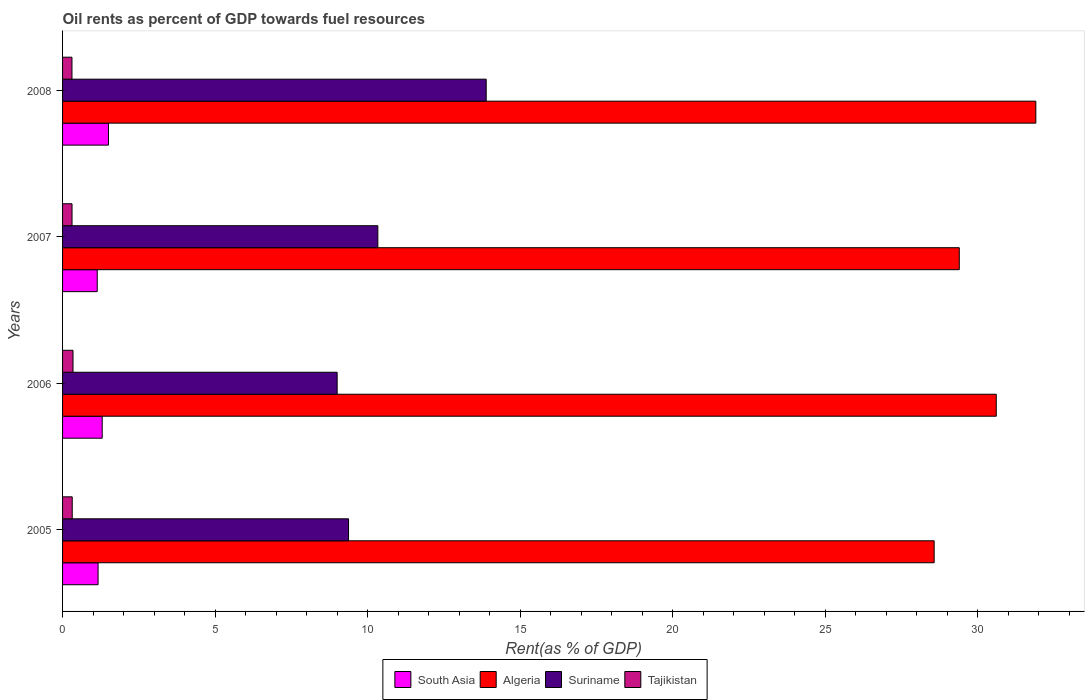How many different coloured bars are there?
Provide a succinct answer. 4. Are the number of bars per tick equal to the number of legend labels?
Ensure brevity in your answer.  Yes. Are the number of bars on each tick of the Y-axis equal?
Give a very brief answer. Yes. How many bars are there on the 1st tick from the top?
Make the answer very short. 4. How many bars are there on the 1st tick from the bottom?
Ensure brevity in your answer.  4. What is the oil rent in Tajikistan in 2007?
Ensure brevity in your answer.  0.31. Across all years, what is the maximum oil rent in South Asia?
Provide a short and direct response. 1.5. Across all years, what is the minimum oil rent in Suriname?
Your answer should be compact. 9. In which year was the oil rent in Suriname maximum?
Offer a very short reply. 2008. In which year was the oil rent in South Asia minimum?
Your answer should be compact. 2007. What is the total oil rent in Tajikistan in the graph?
Provide a short and direct response. 1.28. What is the difference between the oil rent in Tajikistan in 2007 and that in 2008?
Ensure brevity in your answer.  0. What is the difference between the oil rent in Tajikistan in 2006 and the oil rent in South Asia in 2005?
Your answer should be compact. -0.82. What is the average oil rent in South Asia per year?
Offer a terse response. 1.28. In the year 2006, what is the difference between the oil rent in Algeria and oil rent in Suriname?
Ensure brevity in your answer.  21.61. In how many years, is the oil rent in Algeria greater than 7 %?
Offer a terse response. 4. What is the ratio of the oil rent in Tajikistan in 2007 to that in 2008?
Provide a short and direct response. 1.01. Is the difference between the oil rent in Algeria in 2005 and 2006 greater than the difference between the oil rent in Suriname in 2005 and 2006?
Your answer should be very brief. No. What is the difference between the highest and the second highest oil rent in Algeria?
Offer a terse response. 1.3. What is the difference between the highest and the lowest oil rent in Tajikistan?
Your answer should be very brief. 0.03. In how many years, is the oil rent in Tajikistan greater than the average oil rent in Tajikistan taken over all years?
Make the answer very short. 1. Is the sum of the oil rent in South Asia in 2005 and 2008 greater than the maximum oil rent in Tajikistan across all years?
Ensure brevity in your answer.  Yes. Is it the case that in every year, the sum of the oil rent in Algeria and oil rent in Suriname is greater than the sum of oil rent in South Asia and oil rent in Tajikistan?
Provide a succinct answer. Yes. What does the 1st bar from the top in 2007 represents?
Your answer should be very brief. Tajikistan. What does the 1st bar from the bottom in 2005 represents?
Keep it short and to the point. South Asia. Is it the case that in every year, the sum of the oil rent in Algeria and oil rent in Suriname is greater than the oil rent in Tajikistan?
Ensure brevity in your answer.  Yes. How many bars are there?
Make the answer very short. 16. Are all the bars in the graph horizontal?
Keep it short and to the point. Yes. What is the difference between two consecutive major ticks on the X-axis?
Offer a very short reply. 5. Are the values on the major ticks of X-axis written in scientific E-notation?
Offer a terse response. No. Does the graph contain grids?
Make the answer very short. No. What is the title of the graph?
Make the answer very short. Oil rents as percent of GDP towards fuel resources. What is the label or title of the X-axis?
Keep it short and to the point. Rent(as % of GDP). What is the Rent(as % of GDP) of South Asia in 2005?
Provide a succinct answer. 1.16. What is the Rent(as % of GDP) in Algeria in 2005?
Ensure brevity in your answer.  28.57. What is the Rent(as % of GDP) of Suriname in 2005?
Give a very brief answer. 9.38. What is the Rent(as % of GDP) in Tajikistan in 2005?
Offer a terse response. 0.32. What is the Rent(as % of GDP) of South Asia in 2006?
Give a very brief answer. 1.3. What is the Rent(as % of GDP) in Algeria in 2006?
Your answer should be very brief. 30.61. What is the Rent(as % of GDP) of Suriname in 2006?
Keep it short and to the point. 9. What is the Rent(as % of GDP) in Tajikistan in 2006?
Ensure brevity in your answer.  0.34. What is the Rent(as % of GDP) in South Asia in 2007?
Offer a terse response. 1.14. What is the Rent(as % of GDP) in Algeria in 2007?
Offer a terse response. 29.4. What is the Rent(as % of GDP) in Suriname in 2007?
Make the answer very short. 10.34. What is the Rent(as % of GDP) in Tajikistan in 2007?
Offer a very short reply. 0.31. What is the Rent(as % of GDP) in South Asia in 2008?
Offer a very short reply. 1.5. What is the Rent(as % of GDP) of Algeria in 2008?
Make the answer very short. 31.91. What is the Rent(as % of GDP) in Suriname in 2008?
Provide a succinct answer. 13.89. What is the Rent(as % of GDP) in Tajikistan in 2008?
Give a very brief answer. 0.31. Across all years, what is the maximum Rent(as % of GDP) of South Asia?
Provide a succinct answer. 1.5. Across all years, what is the maximum Rent(as % of GDP) in Algeria?
Give a very brief answer. 31.91. Across all years, what is the maximum Rent(as % of GDP) in Suriname?
Offer a very short reply. 13.89. Across all years, what is the maximum Rent(as % of GDP) in Tajikistan?
Give a very brief answer. 0.34. Across all years, what is the minimum Rent(as % of GDP) of South Asia?
Offer a very short reply. 1.14. Across all years, what is the minimum Rent(as % of GDP) of Algeria?
Offer a very short reply. 28.57. Across all years, what is the minimum Rent(as % of GDP) of Suriname?
Provide a succinct answer. 9. Across all years, what is the minimum Rent(as % of GDP) in Tajikistan?
Give a very brief answer. 0.31. What is the total Rent(as % of GDP) of South Asia in the graph?
Provide a succinct answer. 5.11. What is the total Rent(as % of GDP) of Algeria in the graph?
Your answer should be very brief. 120.49. What is the total Rent(as % of GDP) in Suriname in the graph?
Offer a very short reply. 42.6. What is the total Rent(as % of GDP) in Tajikistan in the graph?
Offer a terse response. 1.28. What is the difference between the Rent(as % of GDP) of South Asia in 2005 and that in 2006?
Provide a succinct answer. -0.14. What is the difference between the Rent(as % of GDP) of Algeria in 2005 and that in 2006?
Make the answer very short. -2.04. What is the difference between the Rent(as % of GDP) of Suriname in 2005 and that in 2006?
Keep it short and to the point. 0.37. What is the difference between the Rent(as % of GDP) in Tajikistan in 2005 and that in 2006?
Give a very brief answer. -0.03. What is the difference between the Rent(as % of GDP) of South Asia in 2005 and that in 2007?
Keep it short and to the point. 0.03. What is the difference between the Rent(as % of GDP) of Algeria in 2005 and that in 2007?
Ensure brevity in your answer.  -0.82. What is the difference between the Rent(as % of GDP) in Suriname in 2005 and that in 2007?
Offer a very short reply. -0.96. What is the difference between the Rent(as % of GDP) in Tajikistan in 2005 and that in 2007?
Your answer should be very brief. 0.01. What is the difference between the Rent(as % of GDP) in South Asia in 2005 and that in 2008?
Your answer should be very brief. -0.34. What is the difference between the Rent(as % of GDP) of Algeria in 2005 and that in 2008?
Ensure brevity in your answer.  -3.33. What is the difference between the Rent(as % of GDP) of Suriname in 2005 and that in 2008?
Offer a terse response. -4.51. What is the difference between the Rent(as % of GDP) in Tajikistan in 2005 and that in 2008?
Keep it short and to the point. 0.01. What is the difference between the Rent(as % of GDP) of South Asia in 2006 and that in 2007?
Provide a short and direct response. 0.16. What is the difference between the Rent(as % of GDP) of Algeria in 2006 and that in 2007?
Ensure brevity in your answer.  1.21. What is the difference between the Rent(as % of GDP) in Suriname in 2006 and that in 2007?
Offer a very short reply. -1.33. What is the difference between the Rent(as % of GDP) in Tajikistan in 2006 and that in 2007?
Provide a short and direct response. 0.03. What is the difference between the Rent(as % of GDP) in South Asia in 2006 and that in 2008?
Provide a succinct answer. -0.21. What is the difference between the Rent(as % of GDP) in Algeria in 2006 and that in 2008?
Keep it short and to the point. -1.3. What is the difference between the Rent(as % of GDP) in Suriname in 2006 and that in 2008?
Offer a very short reply. -4.89. What is the difference between the Rent(as % of GDP) in Tajikistan in 2006 and that in 2008?
Your response must be concise. 0.03. What is the difference between the Rent(as % of GDP) of South Asia in 2007 and that in 2008?
Provide a succinct answer. -0.37. What is the difference between the Rent(as % of GDP) in Algeria in 2007 and that in 2008?
Provide a succinct answer. -2.51. What is the difference between the Rent(as % of GDP) of Suriname in 2007 and that in 2008?
Provide a succinct answer. -3.55. What is the difference between the Rent(as % of GDP) in Tajikistan in 2007 and that in 2008?
Provide a short and direct response. 0. What is the difference between the Rent(as % of GDP) in South Asia in 2005 and the Rent(as % of GDP) in Algeria in 2006?
Your answer should be compact. -29.44. What is the difference between the Rent(as % of GDP) in South Asia in 2005 and the Rent(as % of GDP) in Suriname in 2006?
Give a very brief answer. -7.84. What is the difference between the Rent(as % of GDP) of South Asia in 2005 and the Rent(as % of GDP) of Tajikistan in 2006?
Your response must be concise. 0.82. What is the difference between the Rent(as % of GDP) in Algeria in 2005 and the Rent(as % of GDP) in Suriname in 2006?
Keep it short and to the point. 19.57. What is the difference between the Rent(as % of GDP) in Algeria in 2005 and the Rent(as % of GDP) in Tajikistan in 2006?
Ensure brevity in your answer.  28.23. What is the difference between the Rent(as % of GDP) in Suriname in 2005 and the Rent(as % of GDP) in Tajikistan in 2006?
Give a very brief answer. 9.03. What is the difference between the Rent(as % of GDP) in South Asia in 2005 and the Rent(as % of GDP) in Algeria in 2007?
Your response must be concise. -28.23. What is the difference between the Rent(as % of GDP) in South Asia in 2005 and the Rent(as % of GDP) in Suriname in 2007?
Provide a short and direct response. -9.17. What is the difference between the Rent(as % of GDP) in South Asia in 2005 and the Rent(as % of GDP) in Tajikistan in 2007?
Offer a very short reply. 0.85. What is the difference between the Rent(as % of GDP) in Algeria in 2005 and the Rent(as % of GDP) in Suriname in 2007?
Ensure brevity in your answer.  18.24. What is the difference between the Rent(as % of GDP) of Algeria in 2005 and the Rent(as % of GDP) of Tajikistan in 2007?
Ensure brevity in your answer.  28.26. What is the difference between the Rent(as % of GDP) in Suriname in 2005 and the Rent(as % of GDP) in Tajikistan in 2007?
Your response must be concise. 9.07. What is the difference between the Rent(as % of GDP) of South Asia in 2005 and the Rent(as % of GDP) of Algeria in 2008?
Give a very brief answer. -30.74. What is the difference between the Rent(as % of GDP) of South Asia in 2005 and the Rent(as % of GDP) of Suriname in 2008?
Make the answer very short. -12.72. What is the difference between the Rent(as % of GDP) in South Asia in 2005 and the Rent(as % of GDP) in Tajikistan in 2008?
Provide a short and direct response. 0.86. What is the difference between the Rent(as % of GDP) of Algeria in 2005 and the Rent(as % of GDP) of Suriname in 2008?
Your answer should be compact. 14.68. What is the difference between the Rent(as % of GDP) of Algeria in 2005 and the Rent(as % of GDP) of Tajikistan in 2008?
Give a very brief answer. 28.26. What is the difference between the Rent(as % of GDP) in Suriname in 2005 and the Rent(as % of GDP) in Tajikistan in 2008?
Offer a very short reply. 9.07. What is the difference between the Rent(as % of GDP) in South Asia in 2006 and the Rent(as % of GDP) in Algeria in 2007?
Offer a terse response. -28.1. What is the difference between the Rent(as % of GDP) in South Asia in 2006 and the Rent(as % of GDP) in Suriname in 2007?
Your answer should be very brief. -9.04. What is the difference between the Rent(as % of GDP) in Algeria in 2006 and the Rent(as % of GDP) in Suriname in 2007?
Provide a short and direct response. 20.27. What is the difference between the Rent(as % of GDP) of Algeria in 2006 and the Rent(as % of GDP) of Tajikistan in 2007?
Provide a short and direct response. 30.3. What is the difference between the Rent(as % of GDP) in Suriname in 2006 and the Rent(as % of GDP) in Tajikistan in 2007?
Provide a short and direct response. 8.69. What is the difference between the Rent(as % of GDP) of South Asia in 2006 and the Rent(as % of GDP) of Algeria in 2008?
Provide a succinct answer. -30.61. What is the difference between the Rent(as % of GDP) of South Asia in 2006 and the Rent(as % of GDP) of Suriname in 2008?
Your response must be concise. -12.59. What is the difference between the Rent(as % of GDP) of Algeria in 2006 and the Rent(as % of GDP) of Suriname in 2008?
Your response must be concise. 16.72. What is the difference between the Rent(as % of GDP) of Algeria in 2006 and the Rent(as % of GDP) of Tajikistan in 2008?
Offer a terse response. 30.3. What is the difference between the Rent(as % of GDP) in Suriname in 2006 and the Rent(as % of GDP) in Tajikistan in 2008?
Keep it short and to the point. 8.69. What is the difference between the Rent(as % of GDP) of South Asia in 2007 and the Rent(as % of GDP) of Algeria in 2008?
Offer a terse response. -30.77. What is the difference between the Rent(as % of GDP) of South Asia in 2007 and the Rent(as % of GDP) of Suriname in 2008?
Keep it short and to the point. -12.75. What is the difference between the Rent(as % of GDP) in South Asia in 2007 and the Rent(as % of GDP) in Tajikistan in 2008?
Make the answer very short. 0.83. What is the difference between the Rent(as % of GDP) in Algeria in 2007 and the Rent(as % of GDP) in Suriname in 2008?
Ensure brevity in your answer.  15.51. What is the difference between the Rent(as % of GDP) in Algeria in 2007 and the Rent(as % of GDP) in Tajikistan in 2008?
Provide a succinct answer. 29.09. What is the difference between the Rent(as % of GDP) in Suriname in 2007 and the Rent(as % of GDP) in Tajikistan in 2008?
Make the answer very short. 10.03. What is the average Rent(as % of GDP) of South Asia per year?
Your answer should be compact. 1.28. What is the average Rent(as % of GDP) in Algeria per year?
Your response must be concise. 30.12. What is the average Rent(as % of GDP) of Suriname per year?
Keep it short and to the point. 10.65. What is the average Rent(as % of GDP) of Tajikistan per year?
Your response must be concise. 0.32. In the year 2005, what is the difference between the Rent(as % of GDP) of South Asia and Rent(as % of GDP) of Algeria?
Your response must be concise. -27.41. In the year 2005, what is the difference between the Rent(as % of GDP) of South Asia and Rent(as % of GDP) of Suriname?
Offer a very short reply. -8.21. In the year 2005, what is the difference between the Rent(as % of GDP) in South Asia and Rent(as % of GDP) in Tajikistan?
Your answer should be very brief. 0.85. In the year 2005, what is the difference between the Rent(as % of GDP) in Algeria and Rent(as % of GDP) in Suriname?
Your answer should be compact. 19.2. In the year 2005, what is the difference between the Rent(as % of GDP) in Algeria and Rent(as % of GDP) in Tajikistan?
Your answer should be very brief. 28.26. In the year 2005, what is the difference between the Rent(as % of GDP) in Suriname and Rent(as % of GDP) in Tajikistan?
Make the answer very short. 9.06. In the year 2006, what is the difference between the Rent(as % of GDP) of South Asia and Rent(as % of GDP) of Algeria?
Keep it short and to the point. -29.31. In the year 2006, what is the difference between the Rent(as % of GDP) of South Asia and Rent(as % of GDP) of Suriname?
Provide a succinct answer. -7.7. In the year 2006, what is the difference between the Rent(as % of GDP) in South Asia and Rent(as % of GDP) in Tajikistan?
Provide a succinct answer. 0.96. In the year 2006, what is the difference between the Rent(as % of GDP) of Algeria and Rent(as % of GDP) of Suriname?
Provide a short and direct response. 21.61. In the year 2006, what is the difference between the Rent(as % of GDP) of Algeria and Rent(as % of GDP) of Tajikistan?
Keep it short and to the point. 30.27. In the year 2006, what is the difference between the Rent(as % of GDP) of Suriname and Rent(as % of GDP) of Tajikistan?
Your answer should be very brief. 8.66. In the year 2007, what is the difference between the Rent(as % of GDP) of South Asia and Rent(as % of GDP) of Algeria?
Make the answer very short. -28.26. In the year 2007, what is the difference between the Rent(as % of GDP) in South Asia and Rent(as % of GDP) in Suriname?
Give a very brief answer. -9.2. In the year 2007, what is the difference between the Rent(as % of GDP) in South Asia and Rent(as % of GDP) in Tajikistan?
Ensure brevity in your answer.  0.83. In the year 2007, what is the difference between the Rent(as % of GDP) in Algeria and Rent(as % of GDP) in Suriname?
Offer a very short reply. 19.06. In the year 2007, what is the difference between the Rent(as % of GDP) of Algeria and Rent(as % of GDP) of Tajikistan?
Make the answer very short. 29.09. In the year 2007, what is the difference between the Rent(as % of GDP) in Suriname and Rent(as % of GDP) in Tajikistan?
Keep it short and to the point. 10.03. In the year 2008, what is the difference between the Rent(as % of GDP) of South Asia and Rent(as % of GDP) of Algeria?
Offer a very short reply. -30.4. In the year 2008, what is the difference between the Rent(as % of GDP) of South Asia and Rent(as % of GDP) of Suriname?
Ensure brevity in your answer.  -12.38. In the year 2008, what is the difference between the Rent(as % of GDP) in South Asia and Rent(as % of GDP) in Tajikistan?
Ensure brevity in your answer.  1.2. In the year 2008, what is the difference between the Rent(as % of GDP) in Algeria and Rent(as % of GDP) in Suriname?
Provide a succinct answer. 18.02. In the year 2008, what is the difference between the Rent(as % of GDP) of Algeria and Rent(as % of GDP) of Tajikistan?
Your answer should be compact. 31.6. In the year 2008, what is the difference between the Rent(as % of GDP) of Suriname and Rent(as % of GDP) of Tajikistan?
Make the answer very short. 13.58. What is the ratio of the Rent(as % of GDP) of South Asia in 2005 to that in 2006?
Provide a short and direct response. 0.9. What is the ratio of the Rent(as % of GDP) of Algeria in 2005 to that in 2006?
Offer a very short reply. 0.93. What is the ratio of the Rent(as % of GDP) of Suriname in 2005 to that in 2006?
Your answer should be very brief. 1.04. What is the ratio of the Rent(as % of GDP) of Tajikistan in 2005 to that in 2006?
Provide a short and direct response. 0.93. What is the ratio of the Rent(as % of GDP) of South Asia in 2005 to that in 2007?
Keep it short and to the point. 1.02. What is the ratio of the Rent(as % of GDP) in Algeria in 2005 to that in 2007?
Provide a succinct answer. 0.97. What is the ratio of the Rent(as % of GDP) in Suriname in 2005 to that in 2007?
Give a very brief answer. 0.91. What is the ratio of the Rent(as % of GDP) of Tajikistan in 2005 to that in 2007?
Give a very brief answer. 1.02. What is the ratio of the Rent(as % of GDP) of South Asia in 2005 to that in 2008?
Your response must be concise. 0.77. What is the ratio of the Rent(as % of GDP) of Algeria in 2005 to that in 2008?
Your response must be concise. 0.9. What is the ratio of the Rent(as % of GDP) in Suriname in 2005 to that in 2008?
Provide a succinct answer. 0.68. What is the ratio of the Rent(as % of GDP) of Tajikistan in 2005 to that in 2008?
Your response must be concise. 1.03. What is the ratio of the Rent(as % of GDP) of South Asia in 2006 to that in 2007?
Keep it short and to the point. 1.14. What is the ratio of the Rent(as % of GDP) in Algeria in 2006 to that in 2007?
Offer a very short reply. 1.04. What is the ratio of the Rent(as % of GDP) of Suriname in 2006 to that in 2007?
Your answer should be very brief. 0.87. What is the ratio of the Rent(as % of GDP) in Tajikistan in 2006 to that in 2007?
Give a very brief answer. 1.1. What is the ratio of the Rent(as % of GDP) in South Asia in 2006 to that in 2008?
Your answer should be very brief. 0.86. What is the ratio of the Rent(as % of GDP) of Algeria in 2006 to that in 2008?
Provide a short and direct response. 0.96. What is the ratio of the Rent(as % of GDP) in Suriname in 2006 to that in 2008?
Make the answer very short. 0.65. What is the ratio of the Rent(as % of GDP) in Tajikistan in 2006 to that in 2008?
Provide a short and direct response. 1.11. What is the ratio of the Rent(as % of GDP) of South Asia in 2007 to that in 2008?
Keep it short and to the point. 0.76. What is the ratio of the Rent(as % of GDP) of Algeria in 2007 to that in 2008?
Provide a succinct answer. 0.92. What is the ratio of the Rent(as % of GDP) in Suriname in 2007 to that in 2008?
Offer a terse response. 0.74. What is the ratio of the Rent(as % of GDP) in Tajikistan in 2007 to that in 2008?
Give a very brief answer. 1.01. What is the difference between the highest and the second highest Rent(as % of GDP) of South Asia?
Your answer should be very brief. 0.21. What is the difference between the highest and the second highest Rent(as % of GDP) of Algeria?
Your answer should be compact. 1.3. What is the difference between the highest and the second highest Rent(as % of GDP) in Suriname?
Give a very brief answer. 3.55. What is the difference between the highest and the second highest Rent(as % of GDP) in Tajikistan?
Your response must be concise. 0.03. What is the difference between the highest and the lowest Rent(as % of GDP) of South Asia?
Your answer should be very brief. 0.37. What is the difference between the highest and the lowest Rent(as % of GDP) of Algeria?
Provide a short and direct response. 3.33. What is the difference between the highest and the lowest Rent(as % of GDP) in Suriname?
Make the answer very short. 4.89. What is the difference between the highest and the lowest Rent(as % of GDP) of Tajikistan?
Offer a very short reply. 0.03. 